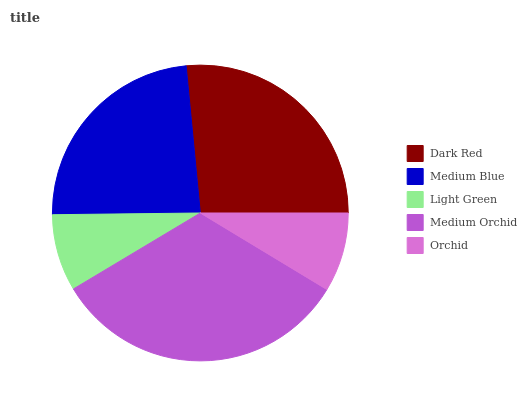Is Light Green the minimum?
Answer yes or no. Yes. Is Medium Orchid the maximum?
Answer yes or no. Yes. Is Medium Blue the minimum?
Answer yes or no. No. Is Medium Blue the maximum?
Answer yes or no. No. Is Dark Red greater than Medium Blue?
Answer yes or no. Yes. Is Medium Blue less than Dark Red?
Answer yes or no. Yes. Is Medium Blue greater than Dark Red?
Answer yes or no. No. Is Dark Red less than Medium Blue?
Answer yes or no. No. Is Medium Blue the high median?
Answer yes or no. Yes. Is Medium Blue the low median?
Answer yes or no. Yes. Is Light Green the high median?
Answer yes or no. No. Is Orchid the low median?
Answer yes or no. No. 